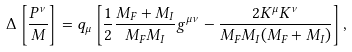Convert formula to latex. <formula><loc_0><loc_0><loc_500><loc_500>\Delta \left [ \frac { P ^ { \nu } } { M } \right ] = q _ { \mu } \left [ \frac { 1 } { 2 } \frac { M _ { F } + M _ { I } } { M _ { F } M _ { I } } g ^ { \mu \nu } - \frac { 2 K ^ { \mu } K ^ { \nu } } { M _ { F } M _ { I } ( M _ { F } + M _ { I } ) } \right ] ,</formula> 